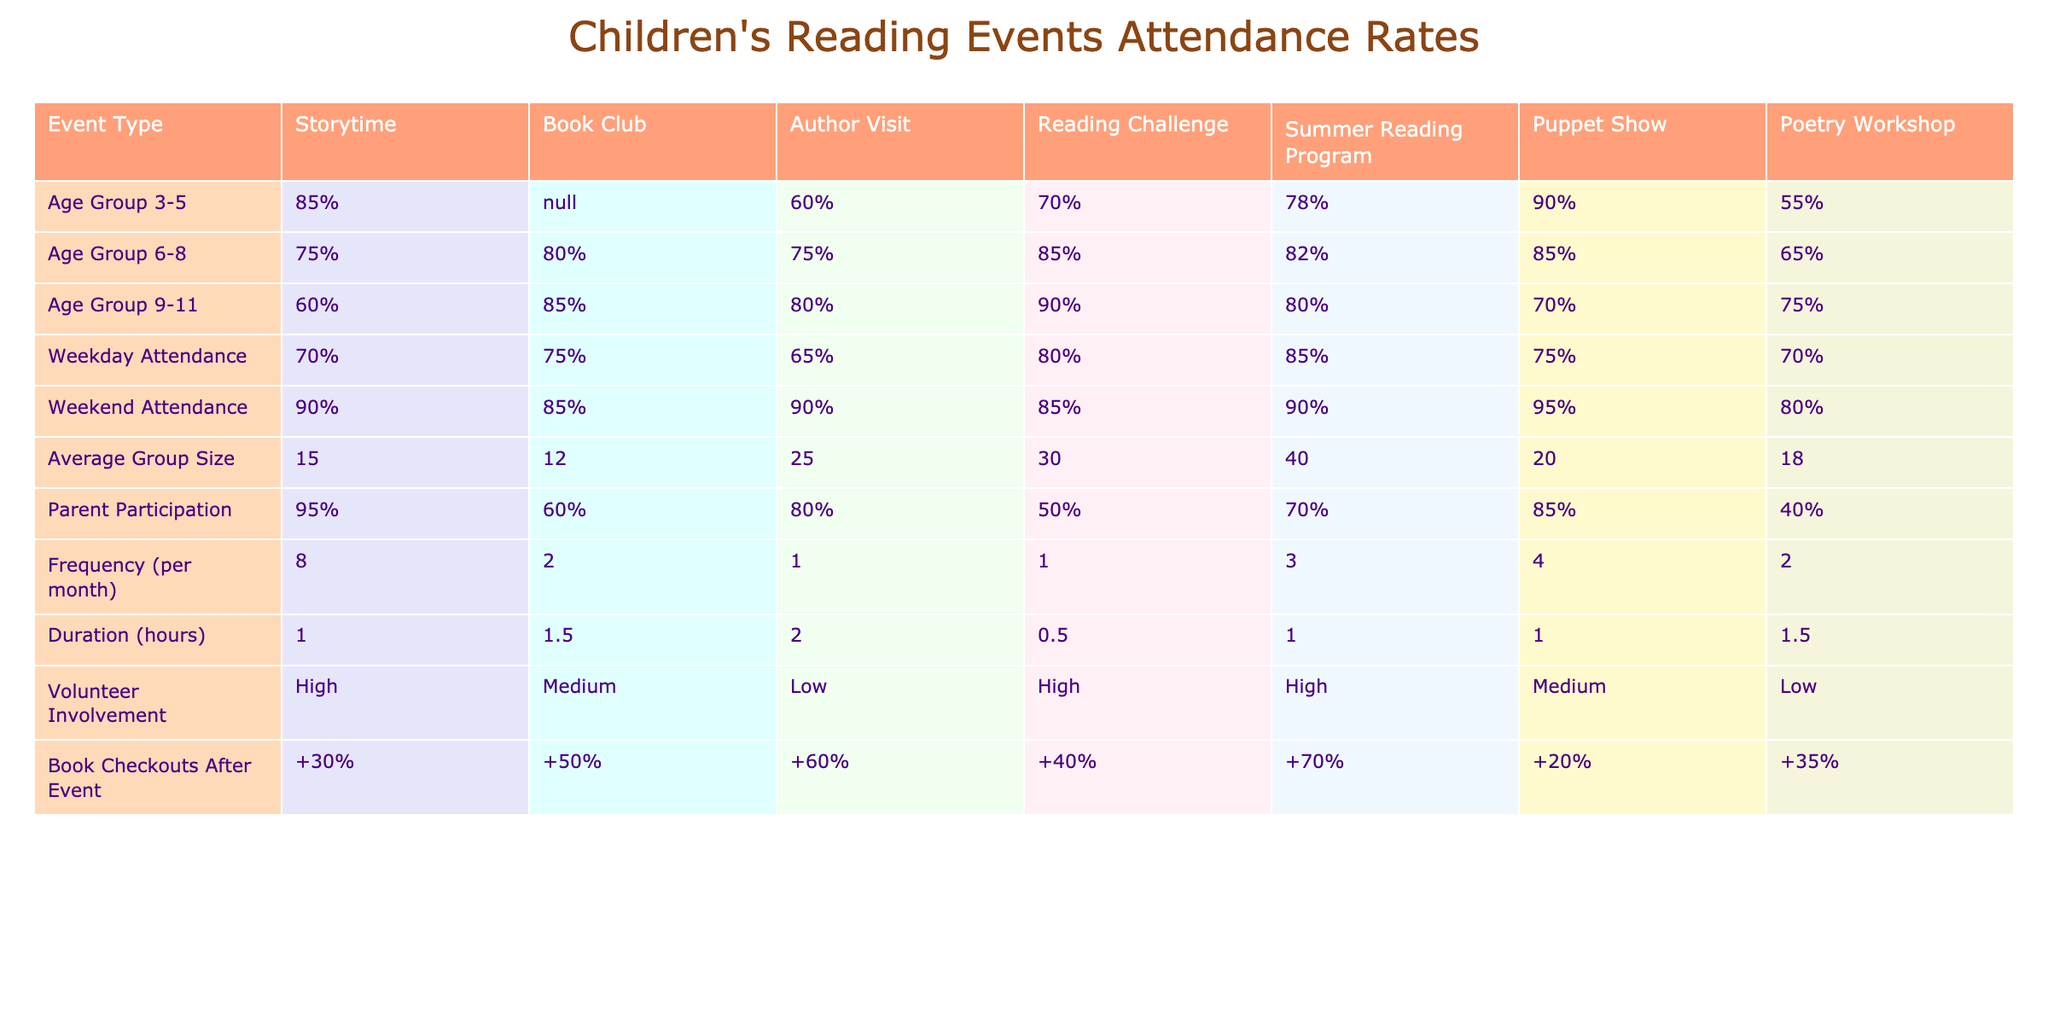What is the attendance rate for the Storytime event for age group 3-5? The attendance rate for the Storytime event is directly listed in the table under the corresponding age group, which shows 85% for age group 3-5.
Answer: 85% Which event has the highest average group size? By comparing the average group sizes listed for each event, the Reading Challenge has the highest average group size of 40.
Answer: 40 What percentage of parents participated in the Puppet Show? The table indicates that parent participation for the Puppet Show is 85%.
Answer: 85% Is the Book Club attendance rate higher for age group 6-8 than for age group 9-11? The attendance for age group 6-8 is 80%, while for age group 9-11 it is 85%, so the Book Club attendance rate is actually lower for age group 6-8.
Answer: No What is the difference in attendance rates between Weekend Attendance and Weekday Attendance for the Summer Reading Program? The Weekend Attendance for the Summer Reading Program is 90% and the Weekday Attendance is 85%. Therefore, the difference is 90% - 85% = 5%.
Answer: 5% What is the average parent participation percentage for all events? To find this, we sum the parent participation rates (95 + 60 + 80 + 50 + 70 + 85 + 40) = 480, and divide by the number of events (7), resulting in an average of 480/7 ≈ 68.57%.
Answer: 68.57% For which event type did the children show the highest percentage of Book Checkouts After the Event? By looking across the table, the Author Visit has the highest percentage at +60%.
Answer: +60% Which event has both high volunteer involvement and parent participation above 70%? The Summer Reading Program has high volunteer involvement and parent participation at 70%.
Answer: Summer Reading Program What is the total frequency of all events combined? The frequencies for all events are 8, 2, 1, 1, 3, 4, 2. Adding these gives 8 + 2 + 1 + 1 + 3 + 4 + 2 = 21.
Answer: 21 Is the Poetry Workshop event less popular in terms of attendance compared to the Puppet Show event for age group 6-8? The attendance rate for the Poetry Workshop is 65% for age group 6-8, while for the Puppet Show it is 85%, meaning the Poetry Workshop is less popular.
Answer: Yes 